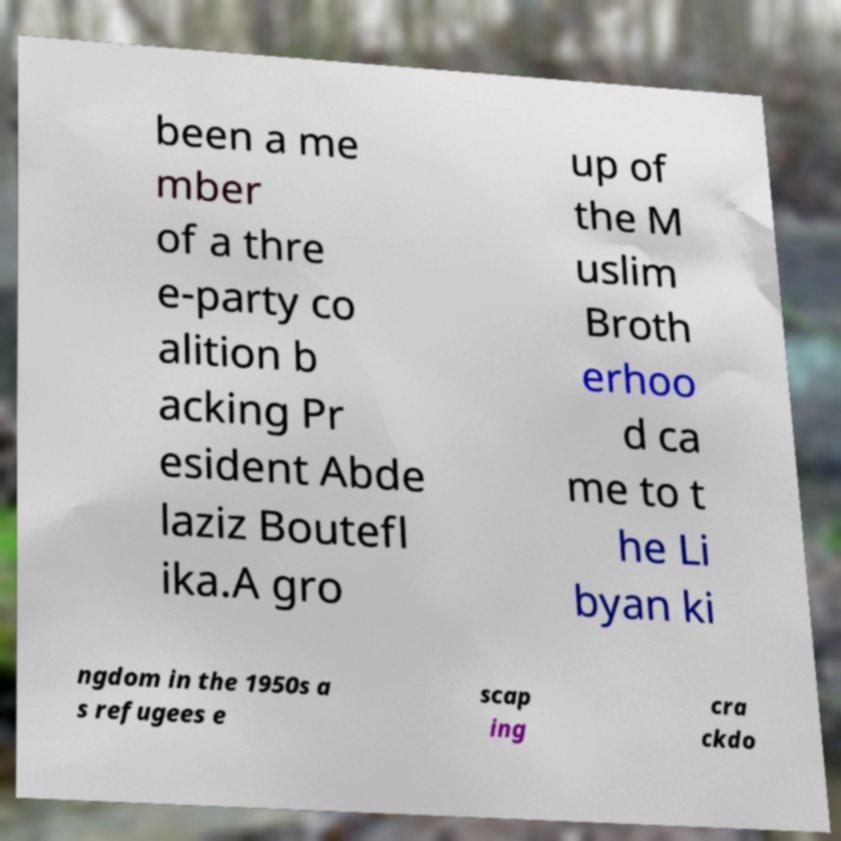What messages or text are displayed in this image? I need them in a readable, typed format. been a me mber of a thre e-party co alition b acking Pr esident Abde laziz Boutefl ika.A gro up of the M uslim Broth erhoo d ca me to t he Li byan ki ngdom in the 1950s a s refugees e scap ing cra ckdo 